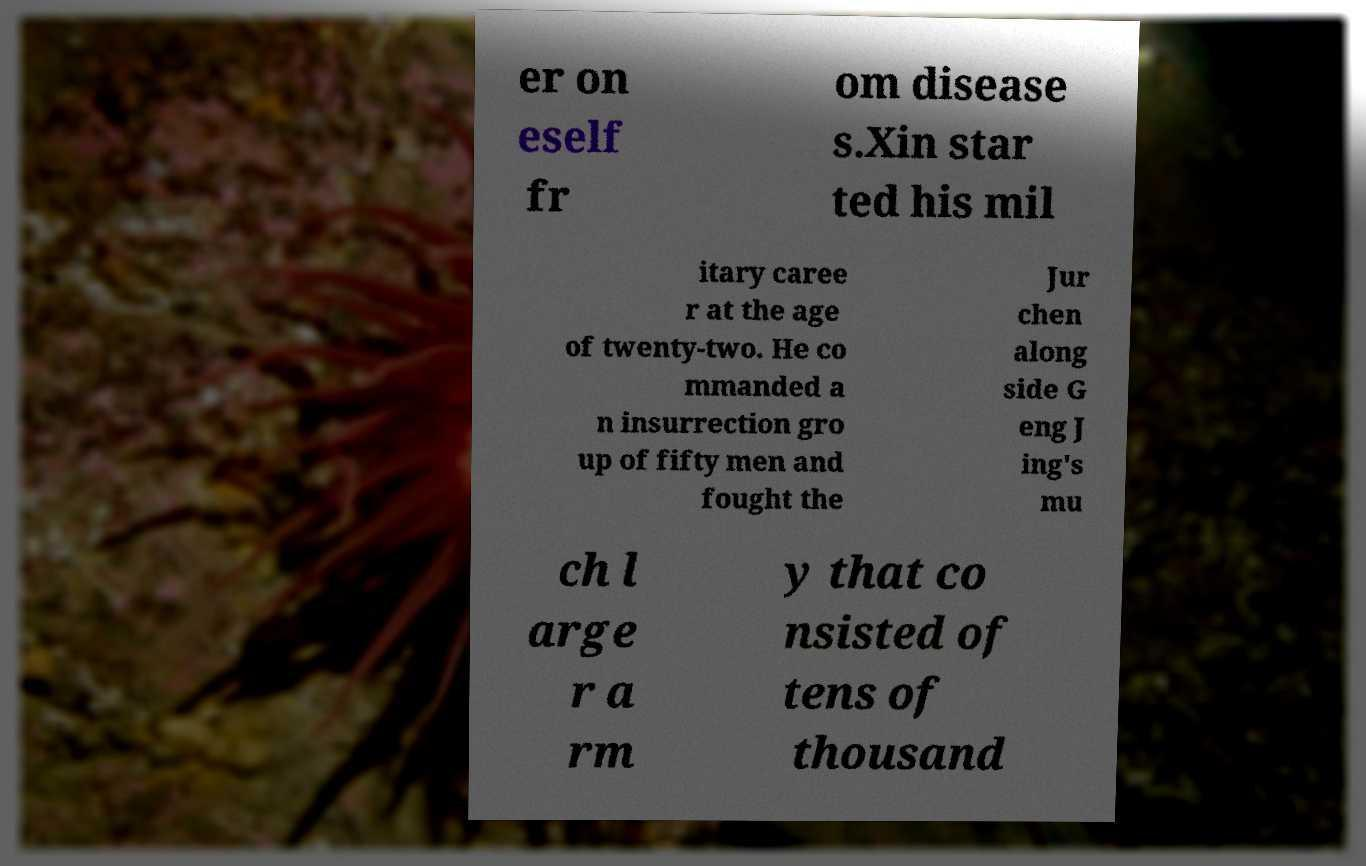I need the written content from this picture converted into text. Can you do that? er on eself fr om disease s.Xin star ted his mil itary caree r at the age of twenty-two. He co mmanded a n insurrection gro up of fifty men and fought the Jur chen along side G eng J ing's mu ch l arge r a rm y that co nsisted of tens of thousand 